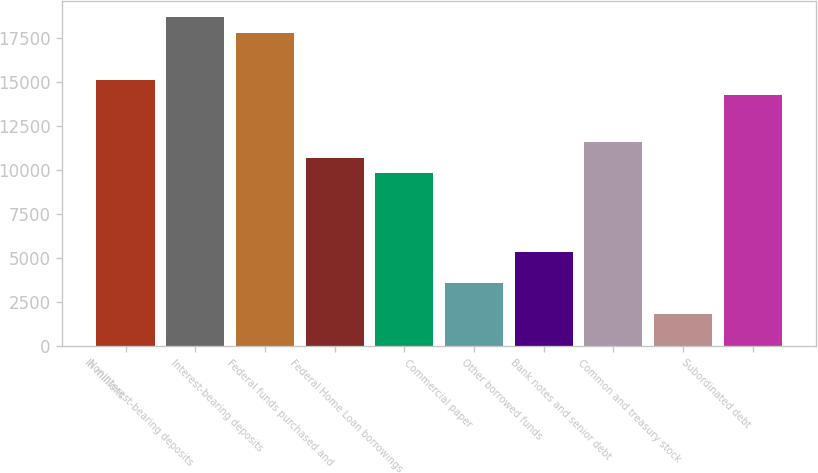Convert chart to OTSL. <chart><loc_0><loc_0><loc_500><loc_500><bar_chart><fcel>In millions<fcel>Noninterest-bearing deposits<fcel>Interest-bearing deposits<fcel>Federal funds purchased and<fcel>Federal Home Loan borrowings<fcel>Commercial paper<fcel>Other borrowed funds<fcel>Bank notes and senior debt<fcel>Common and treasury stock<fcel>Subordinated debt<nl><fcel>15116.6<fcel>18663.8<fcel>17777<fcel>10682.6<fcel>9795.8<fcel>3588.2<fcel>5361.8<fcel>11569.4<fcel>1814.6<fcel>14229.8<nl></chart> 